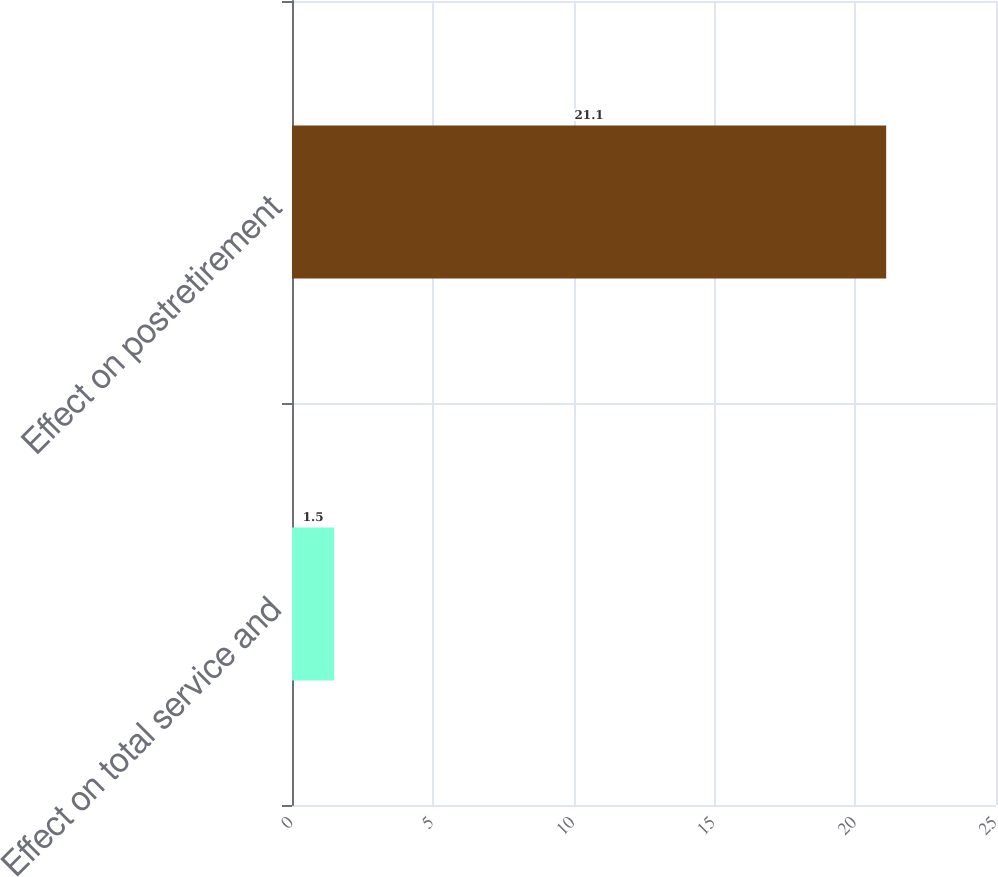<chart> <loc_0><loc_0><loc_500><loc_500><bar_chart><fcel>Effect on total service and<fcel>Effect on postretirement<nl><fcel>1.5<fcel>21.1<nl></chart> 